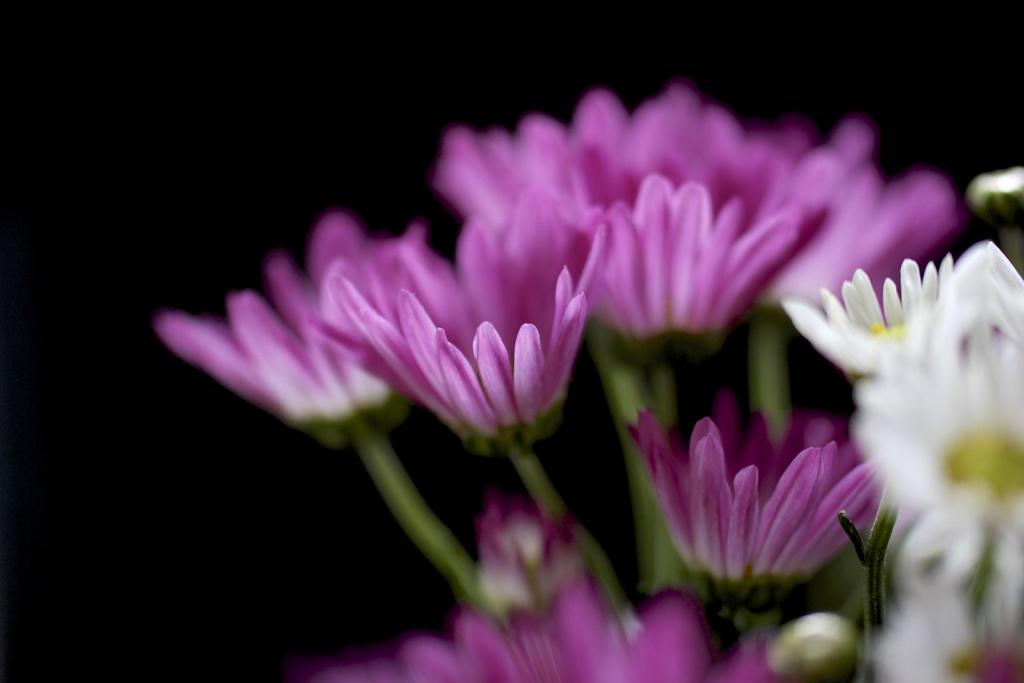What type of plants can be seen in the image? There are flowers in the image. Can you describe the colors of the flowers? Some of the flowers are purple, and some are white. What type of learning is taking place in the image? There is no learning activity depicted in the image; it features flowers of different colors. 